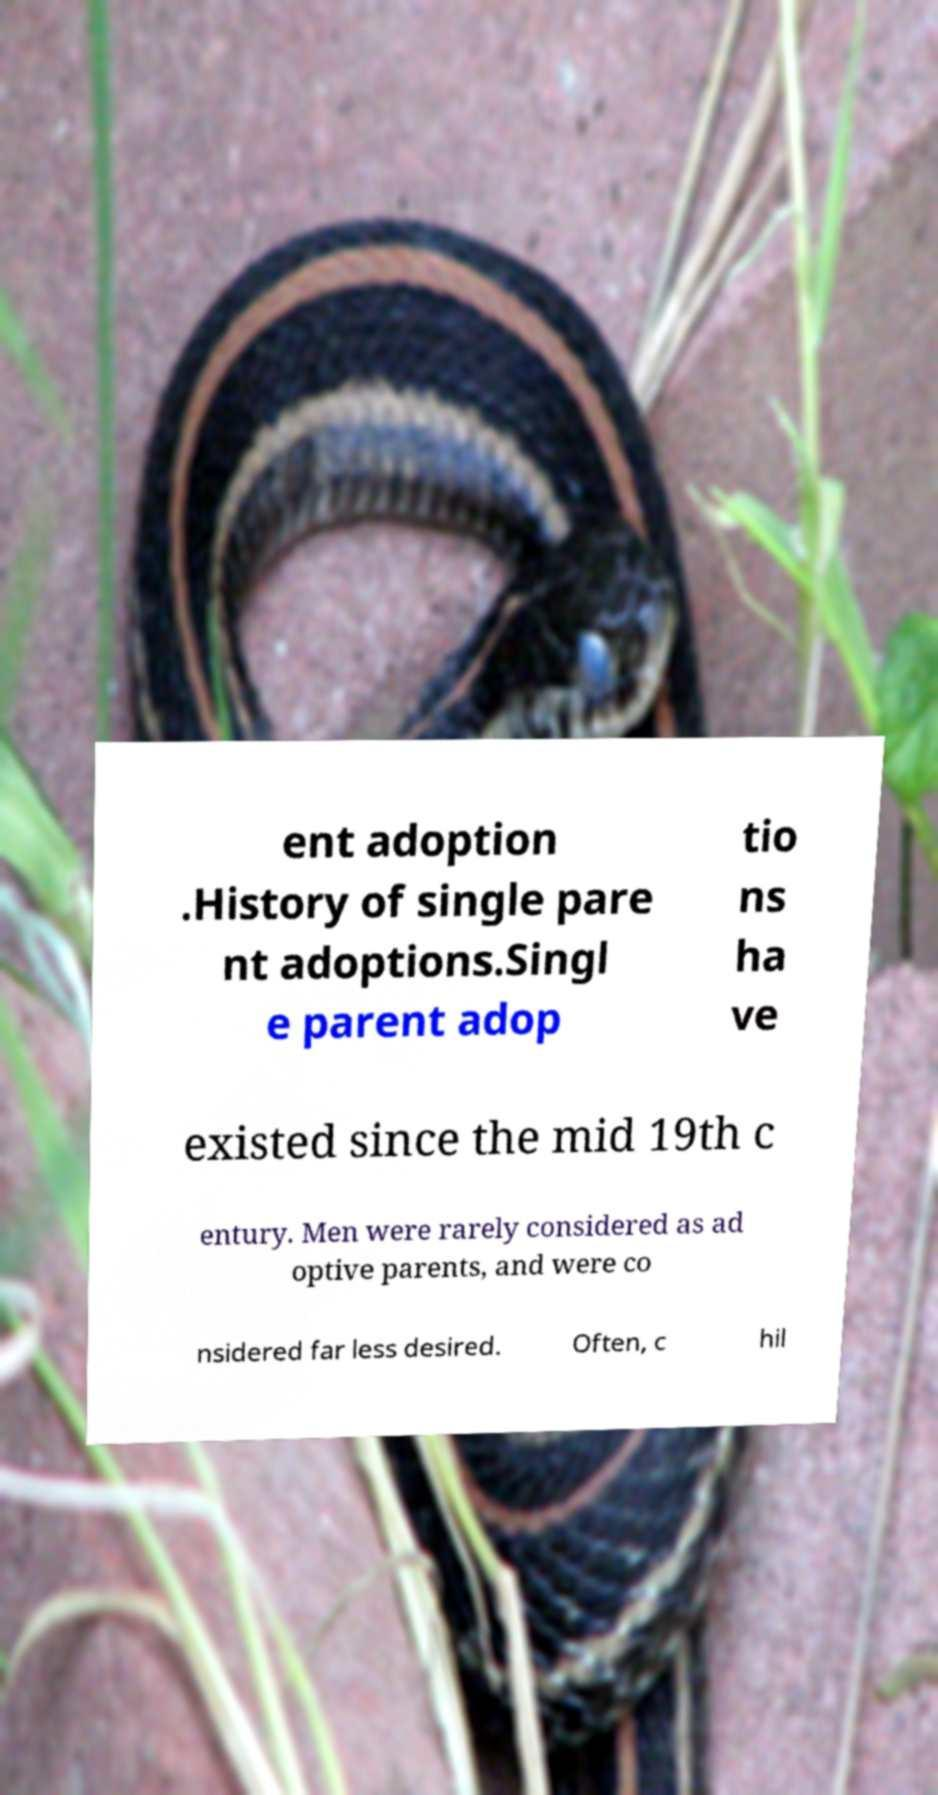Could you assist in decoding the text presented in this image and type it out clearly? ent adoption .History of single pare nt adoptions.Singl e parent adop tio ns ha ve existed since the mid 19th c entury. Men were rarely considered as ad optive parents, and were co nsidered far less desired. Often, c hil 